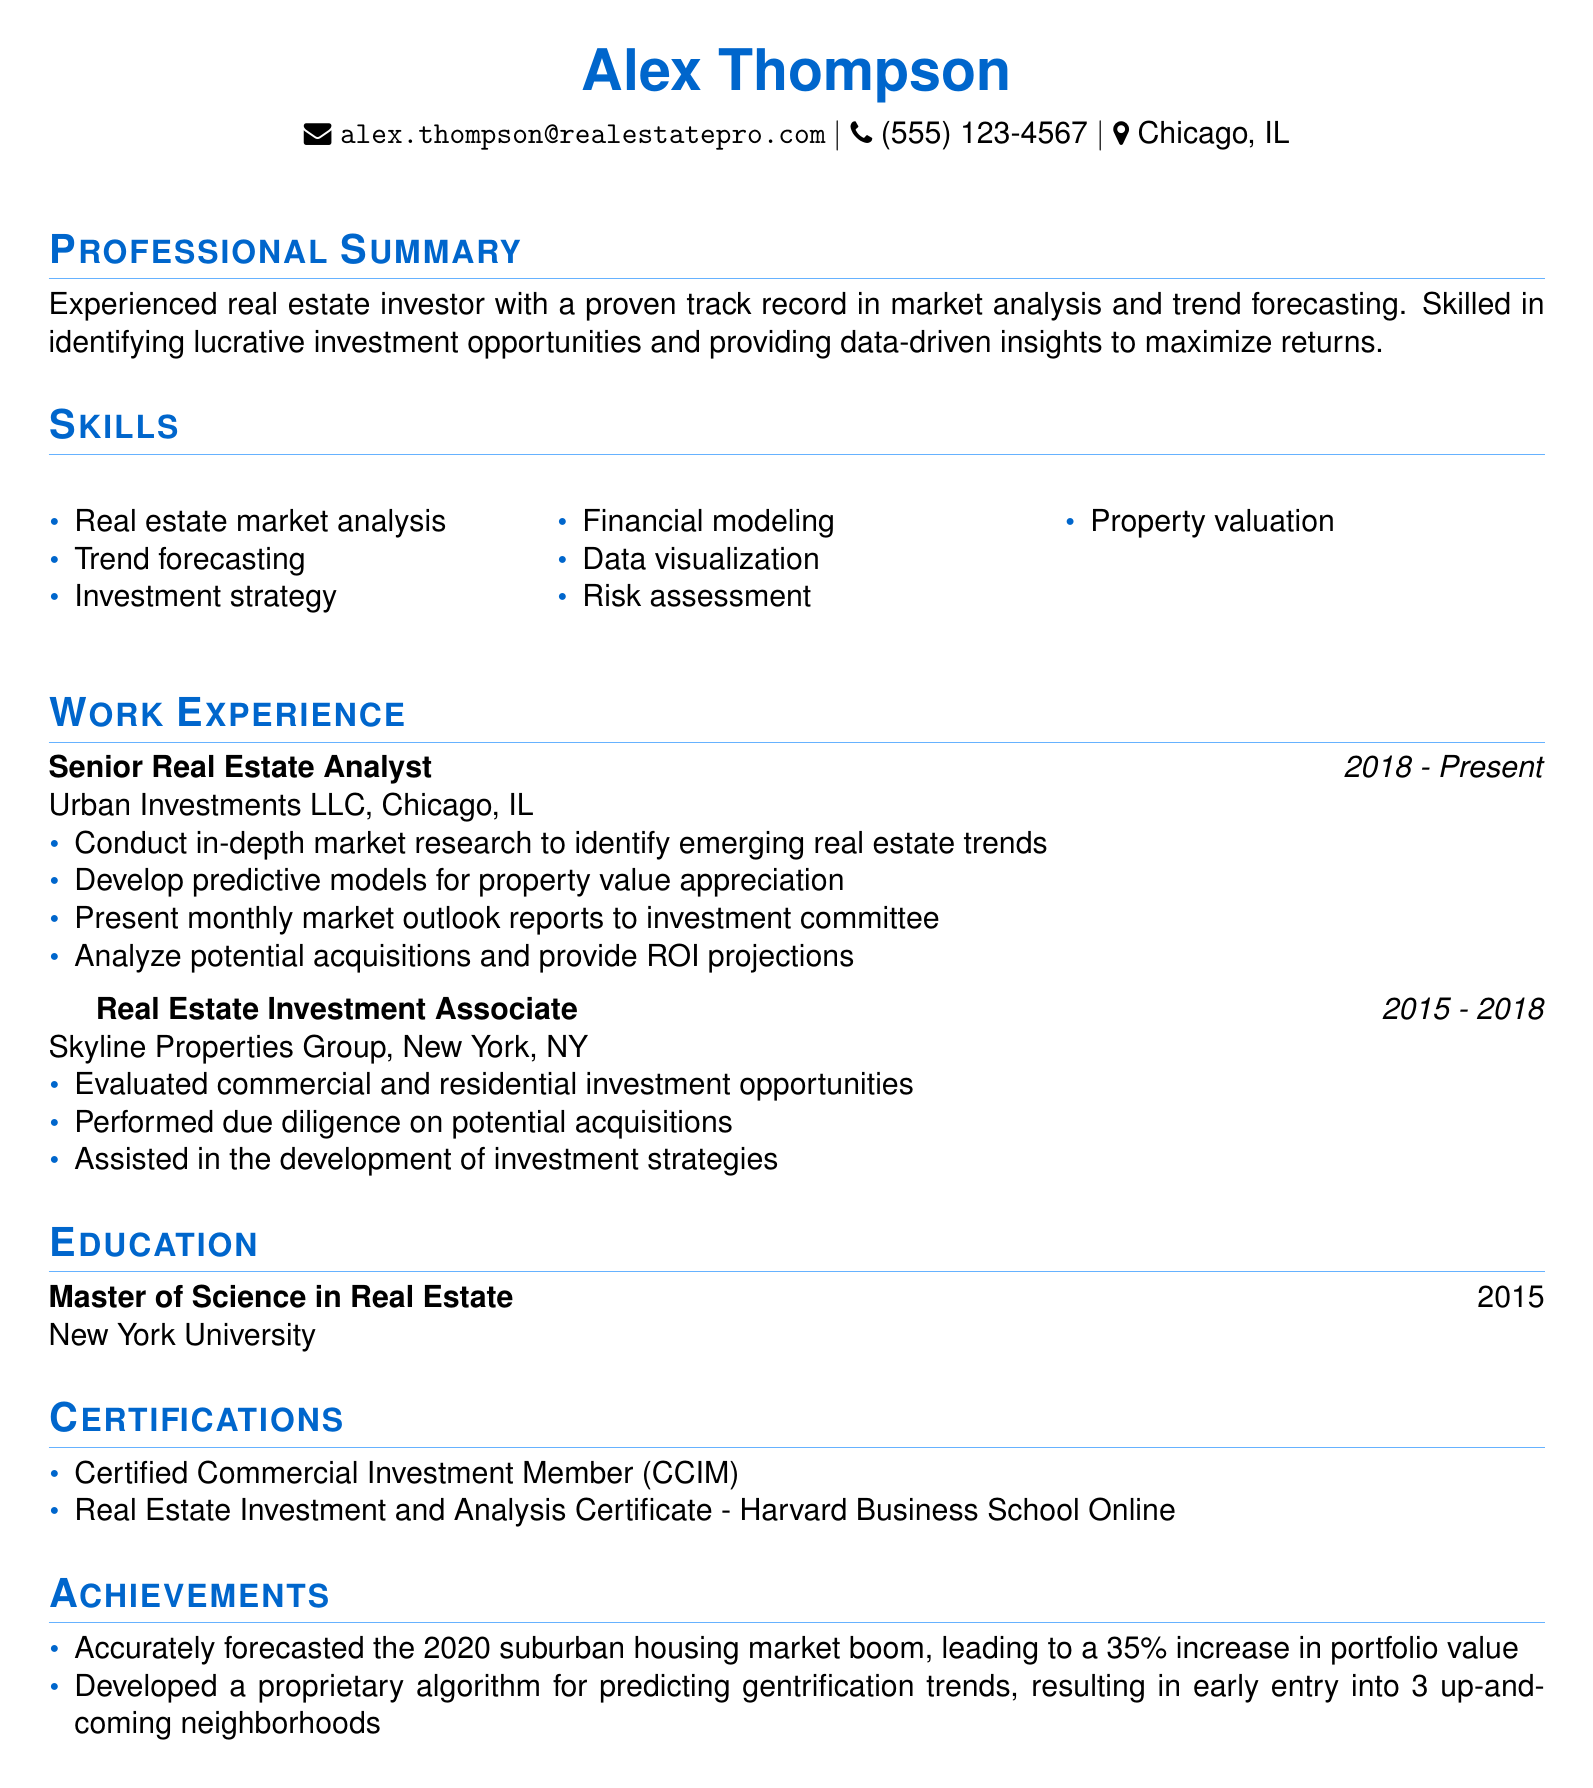what is the name of the individual? The name of the individual is stated prominently at the top of the resume.
Answer: Alex Thompson what is the email address provided? The email address is listed in the personal information section of the resume.
Answer: alex.thompson@realestatepro.com which company does Alex currently work for? The current employment is mentioned in the work experience section.
Answer: Urban Investments LLC what certification does Alex have from Harvard Business School? The certifications section includes specific credentials earned by Alex.
Answer: Real Estate Investment and Analysis Certificate how many years of experience does Alex have as a Senior Real Estate Analyst? The duration of this position is provided in the work experience section.
Answer: 5 years which degree did Alex obtain and from which institution? This information is found in the education section of the resume.
Answer: Master of Science in Real Estate from New York University what significant achievement is highlighted regarding the 2020 market? Achievements are listed concerning Alex's impact in the real estate market.
Answer: 35% increase in portfolio value what skill is specifically mentioned related to financial performance? Skills listed indicate areas of proficiency relevant to the real estate profession.
Answer: Financial modeling how many positions did Alex hold before becoming a Senior Real Estate Analyst? The work experience section details Alex's previous roles before the current one.
Answer: 1 position what was the duration of Alex's employment at Skyline Properties Group? The employment duration is noted in the work experience section of the resume.
Answer: 3 years 